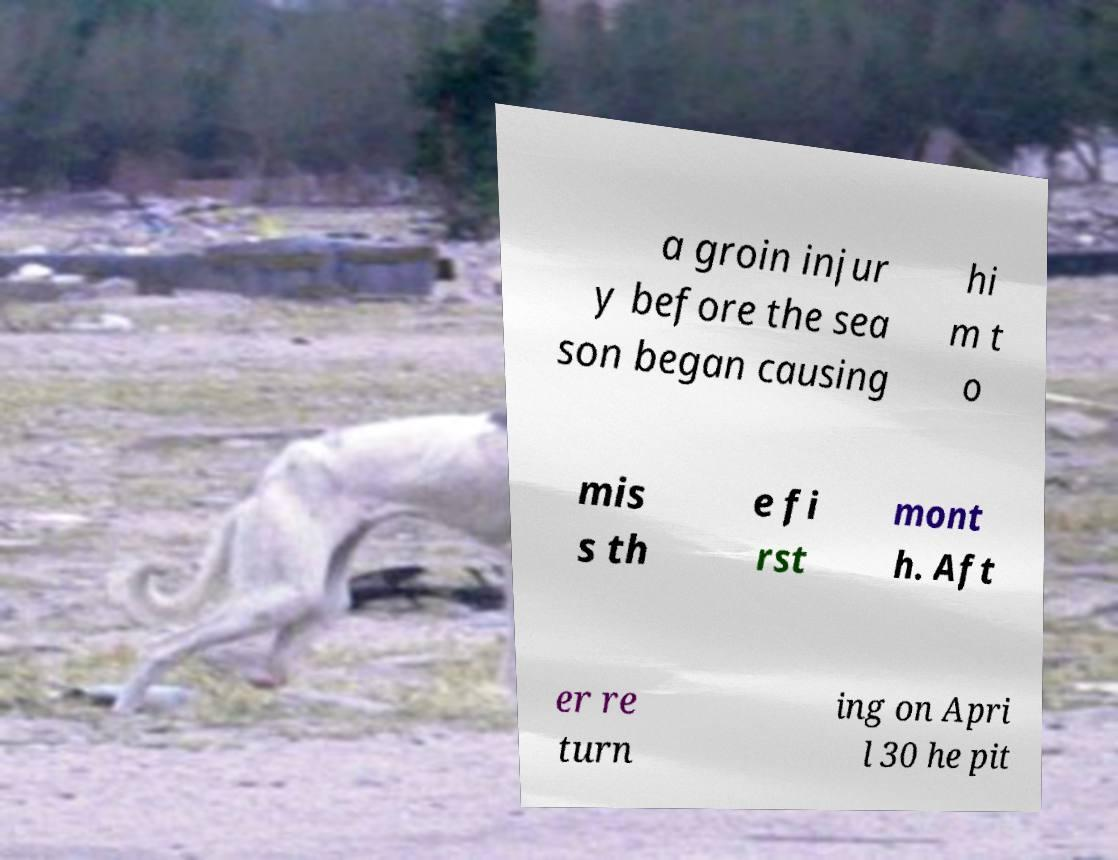Please read and relay the text visible in this image. What does it say? a groin injur y before the sea son began causing hi m t o mis s th e fi rst mont h. Aft er re turn ing on Apri l 30 he pit 